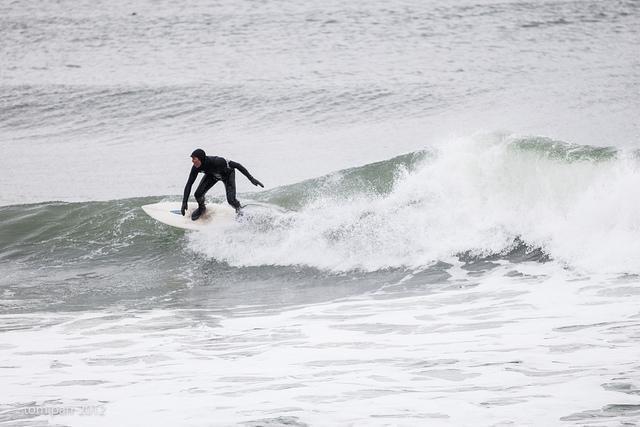How many surfers are there?
Give a very brief answer. 1. How many people are there?
Give a very brief answer. 1. 